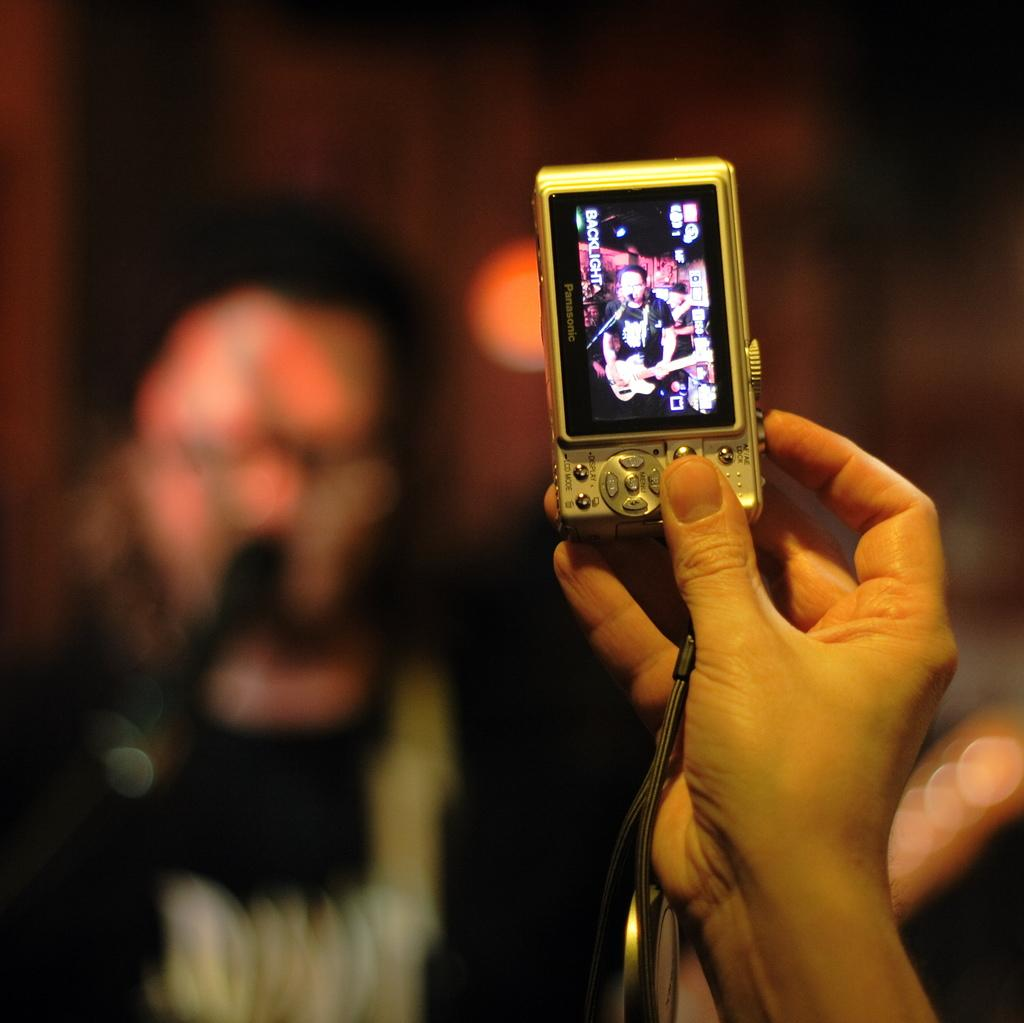What is the main subject in the foreground of the image? There is a hand holding a camera in the foreground of the image. What is the camera capturing in the image? The camera is capturing a person playing guitar and singing. How would you describe the background of the image? The background of the image is blurry. What type of summer game is being played in the image? There is no summer game present in the image; it features a person playing guitar and singing. What color is the hair of the person playing guitar in the image? There is no person's hair visible in the image, as the camera is capturing the scene from a distance and the background is blurry. 